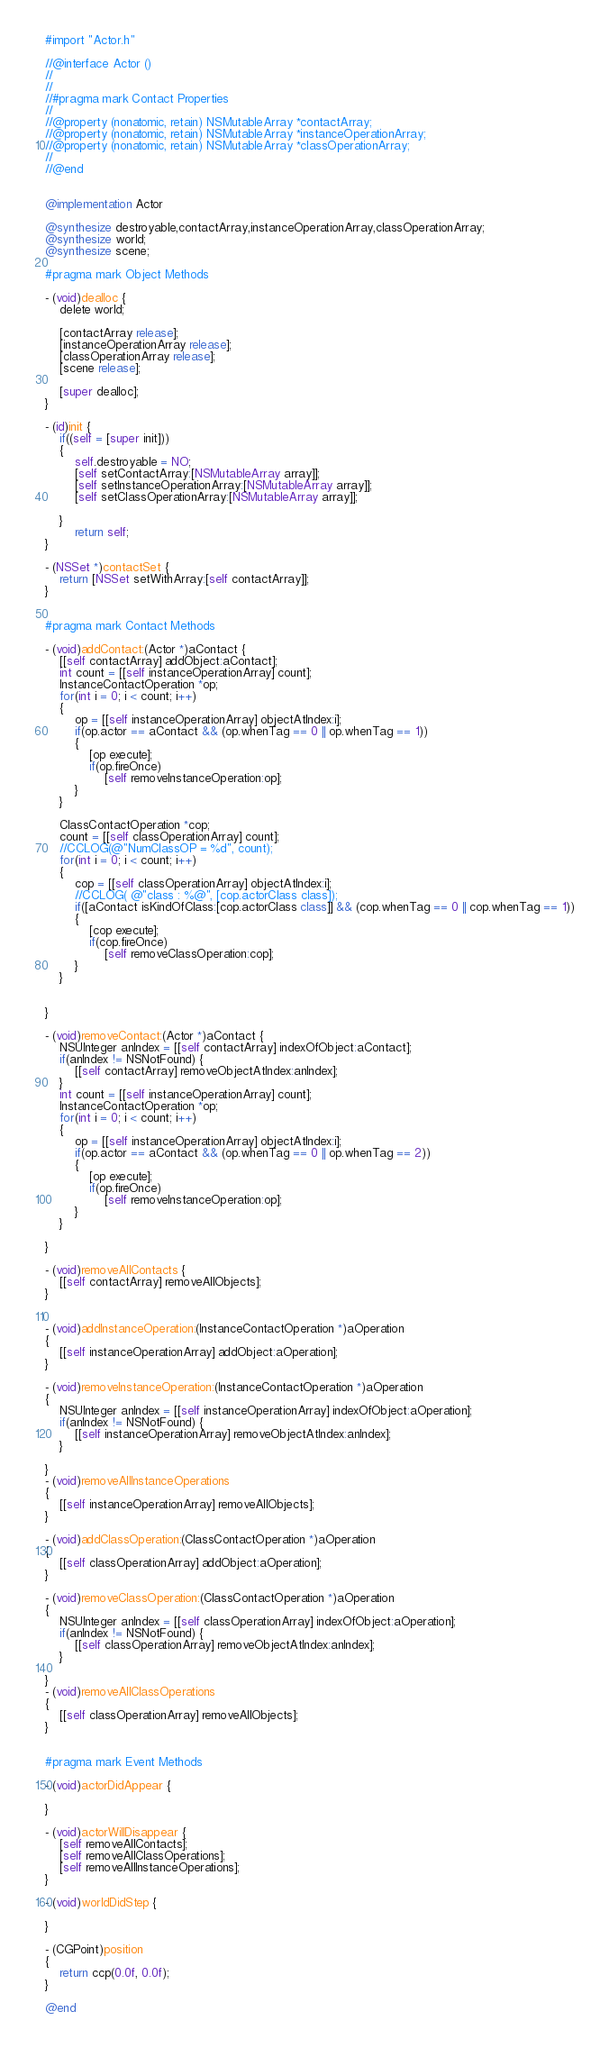Convert code to text. <code><loc_0><loc_0><loc_500><loc_500><_ObjectiveC_>#import "Actor.h"

//@interface Actor ()
//
//
//#pragma mark Contact Properties
//
//@property (nonatomic, retain) NSMutableArray *contactArray;
//@property (nonatomic, retain) NSMutableArray *instanceOperationArray;
//@property (nonatomic, retain) NSMutableArray *classOperationArray;
//
//@end


@implementation Actor

@synthesize destroyable,contactArray,instanceOperationArray,classOperationArray;
@synthesize world;
@synthesize scene;

#pragma mark Object Methods

- (void)dealloc {
    delete world;
    
    [contactArray release];
    [instanceOperationArray release];
    [classOperationArray release];
    [scene release];
	
    [super dealloc];
}

- (id)init {
	if((self = [super init]))
    {
        self.destroyable = NO;
		[self setContactArray:[NSMutableArray array]];
        [self setInstanceOperationArray:[NSMutableArray array]];
        [self setClassOperationArray:[NSMutableArray array]];

	}
        return self;
}

- (NSSet *)contactSet {
	return [NSSet setWithArray:[self contactArray]];
}


#pragma mark Contact Methods

- (void)addContact:(Actor *)aContact {
	[[self contactArray] addObject:aContact];
    int count = [[self instanceOperationArray] count];
    InstanceContactOperation *op;
    for(int i = 0; i < count; i++)
    {
        op = [[self instanceOperationArray] objectAtIndex:i];
        if(op.actor == aContact && (op.whenTag == 0 || op.whenTag == 1))
        {
            [op execute];
            if(op.fireOnce)
                [self removeInstanceOperation:op];
        }
    }
    
    ClassContactOperation *cop;
    count = [[self classOperationArray] count];
    //CCLOG(@"NumClassOP = %d", count);
    for(int i = 0; i < count; i++)
    {
        cop = [[self classOperationArray] objectAtIndex:i];
        //CCLOG( @"class : %@", [cop.actorClass class]);
        if([aContact isKindOfClass:[cop.actorClass class]] && (cop.whenTag == 0 || cop.whenTag == 1))
        { 
            [cop execute];
            if(cop.fireOnce)
                [self removeClassOperation:cop];
        }
    }
    

}

- (void)removeContact:(Actor *)aContact {
	NSUInteger anIndex = [[self contactArray] indexOfObject:aContact];
	if(anIndex != NSNotFound) {
		[[self contactArray] removeObjectAtIndex:anIndex];
	}
    int count = [[self instanceOperationArray] count];
    InstanceContactOperation *op;
    for(int i = 0; i < count; i++)
    {
        op = [[self instanceOperationArray] objectAtIndex:i];
        if(op.actor == aContact && (op.whenTag == 0 || op.whenTag == 2))
        {
            [op execute];
            if(op.fireOnce)
                [self removeInstanceOperation:op];
        }
    }

}

- (void)removeAllContacts {
	[[self contactArray] removeAllObjects];
}


- (void)addInstanceOperation:(InstanceContactOperation *)aOperation
{
    [[self instanceOperationArray] addObject:aOperation];
}

- (void)removeInstanceOperation:(InstanceContactOperation *)aOperation
{
    NSUInteger anIndex = [[self instanceOperationArray] indexOfObject:aOperation];
	if(anIndex != NSNotFound) {
		[[self instanceOperationArray] removeObjectAtIndex:anIndex];
	}

}
- (void)removeAllInstanceOperations
{
    [[self instanceOperationArray] removeAllObjects];
}

- (void)addClassOperation:(ClassContactOperation *)aOperation
{
    [[self classOperationArray] addObject:aOperation];
}

- (void)removeClassOperation:(ClassContactOperation *)aOperation
{
    NSUInteger anIndex = [[self classOperationArray] indexOfObject:aOperation];
	if(anIndex != NSNotFound) {
		[[self classOperationArray] removeObjectAtIndex:anIndex];
	}
    
}
- (void)removeAllClassOperations
{
    [[self classOperationArray] removeAllObjects];
}


#pragma mark Event Methods

- (void)actorDidAppear {
	
}

- (void)actorWillDisappear {
    [self removeAllContacts];
    [self removeAllClassOperations];
    [self removeAllInstanceOperations];
}

- (void)worldDidStep {
	
}

- (CGPoint)position
{
    return ccp(0.0f, 0.0f);
}

@end
</code> 